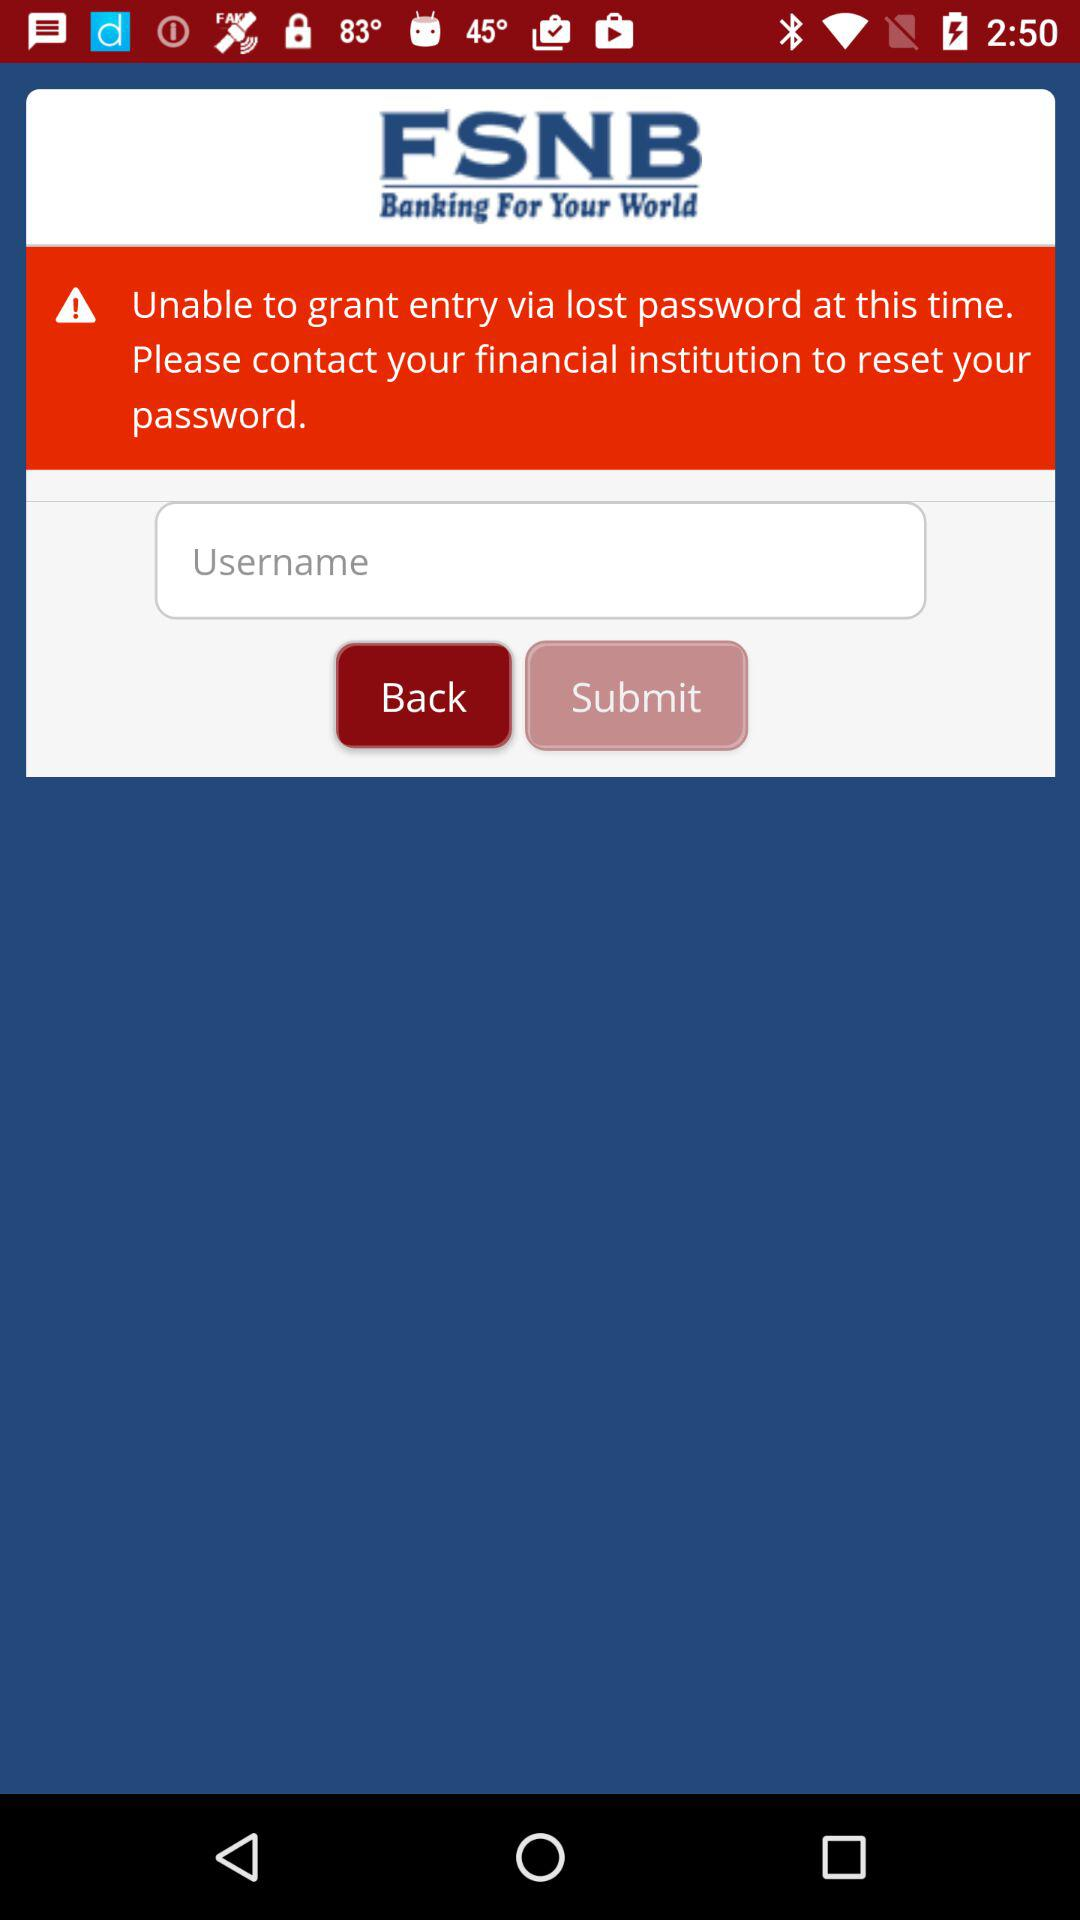Whom should I contact to reset the password? You should contact your financial institution to reset the password. 